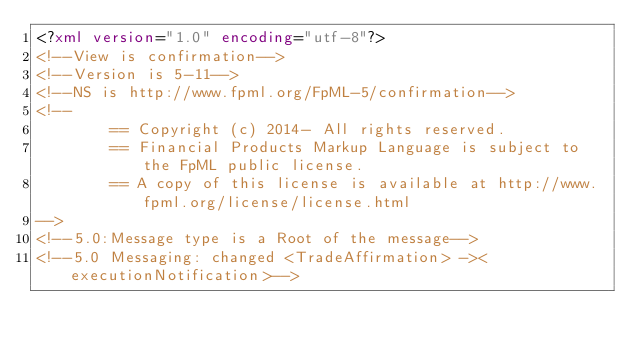Convert code to text. <code><loc_0><loc_0><loc_500><loc_500><_XML_><?xml version="1.0" encoding="utf-8"?>
<!--View is confirmation-->
<!--Version is 5-11-->
<!--NS is http://www.fpml.org/FpML-5/confirmation-->
<!--
        == Copyright (c) 2014- All rights reserved.
        == Financial Products Markup Language is subject to the FpML public license.
        == A copy of this license is available at http://www.fpml.org/license/license.html
-->
<!--5.0:Message type is a Root of the message-->
<!--5.0 Messaging: changed <TradeAffirmation> -><executionNotification>--></code> 